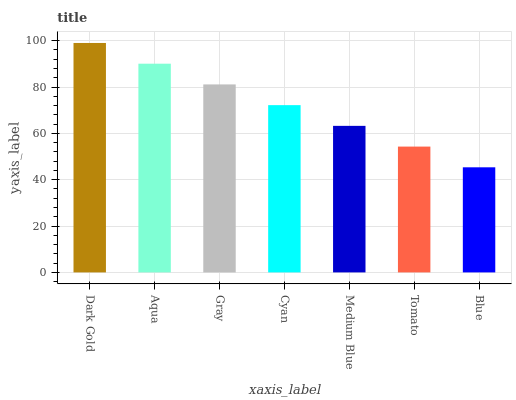Is Blue the minimum?
Answer yes or no. Yes. Is Dark Gold the maximum?
Answer yes or no. Yes. Is Aqua the minimum?
Answer yes or no. No. Is Aqua the maximum?
Answer yes or no. No. Is Dark Gold greater than Aqua?
Answer yes or no. Yes. Is Aqua less than Dark Gold?
Answer yes or no. Yes. Is Aqua greater than Dark Gold?
Answer yes or no. No. Is Dark Gold less than Aqua?
Answer yes or no. No. Is Cyan the high median?
Answer yes or no. Yes. Is Cyan the low median?
Answer yes or no. Yes. Is Medium Blue the high median?
Answer yes or no. No. Is Dark Gold the low median?
Answer yes or no. No. 